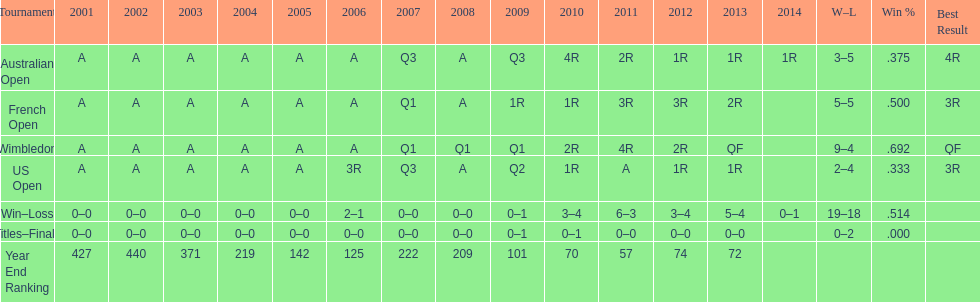Could you parse the entire table as a dict? {'header': ['Tournament', '2001', '2002', '2003', '2004', '2005', '2006', '2007', '2008', '2009', '2010', '2011', '2012', '2013', '2014', 'W–L', 'Win %', 'Best Result'], 'rows': [['Australian Open', 'A', 'A', 'A', 'A', 'A', 'A', 'Q3', 'A', 'Q3', '4R', '2R', '1R', '1R', '1R', '3–5', '.375', '4R'], ['French Open', 'A', 'A', 'A', 'A', 'A', 'A', 'Q1', 'A', '1R', '1R', '3R', '3R', '2R', '', '5–5', '.500', '3R'], ['Wimbledon', 'A', 'A', 'A', 'A', 'A', 'A', 'Q1', 'Q1', 'Q1', '2R', '4R', '2R', 'QF', '', '9–4', '.692', 'QF'], ['US Open', 'A', 'A', 'A', 'A', 'A', '3R', 'Q3', 'A', 'Q2', '1R', 'A', '1R', '1R', '', '2–4', '.333', '3R'], ['Win–Loss', '0–0', '0–0', '0–0', '0–0', '0–0', '2–1', '0–0', '0–0', '0–1', '3–4', '6–3', '3–4', '5–4', '0–1', '19–18', '.514', ''], ['Titles–Finals', '0–0', '0–0', '0–0', '0–0', '0–0', '0–0', '0–0', '0–0', '0–1', '0–1', '0–0', '0–0', '0–0', '', '0–2', '.000', ''], ['Year End Ranking', '427', '440', '371', '219', '142', '125', '222', '209', '101', '70', '57', '74', '72', '', '', '', '']]} How many tournaments had 5 total losses? 2. 